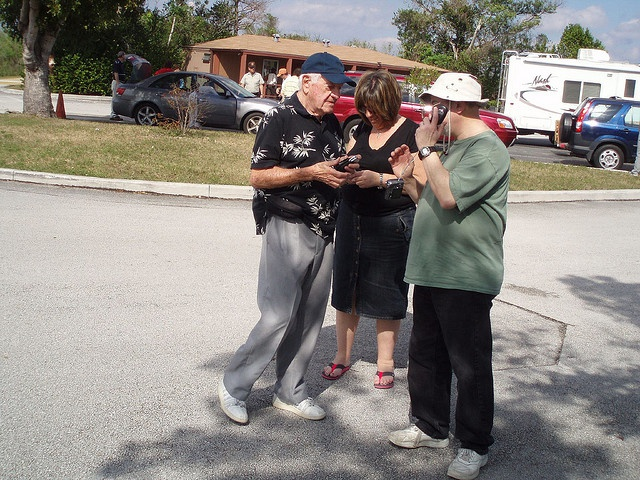Describe the objects in this image and their specific colors. I can see people in black, gray, darkgray, and white tones, people in black, gray, darkgray, and tan tones, people in black, gray, and maroon tones, truck in black, white, darkgray, and gray tones, and car in black, gray, darkgray, and maroon tones in this image. 